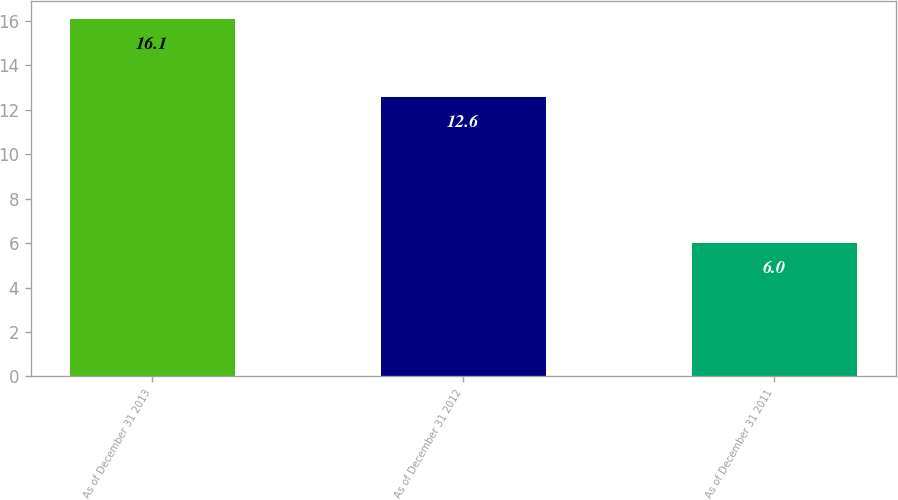Convert chart to OTSL. <chart><loc_0><loc_0><loc_500><loc_500><bar_chart><fcel>As of December 31 2013<fcel>As of December 31 2012<fcel>As of December 31 2011<nl><fcel>16.1<fcel>12.6<fcel>6<nl></chart> 